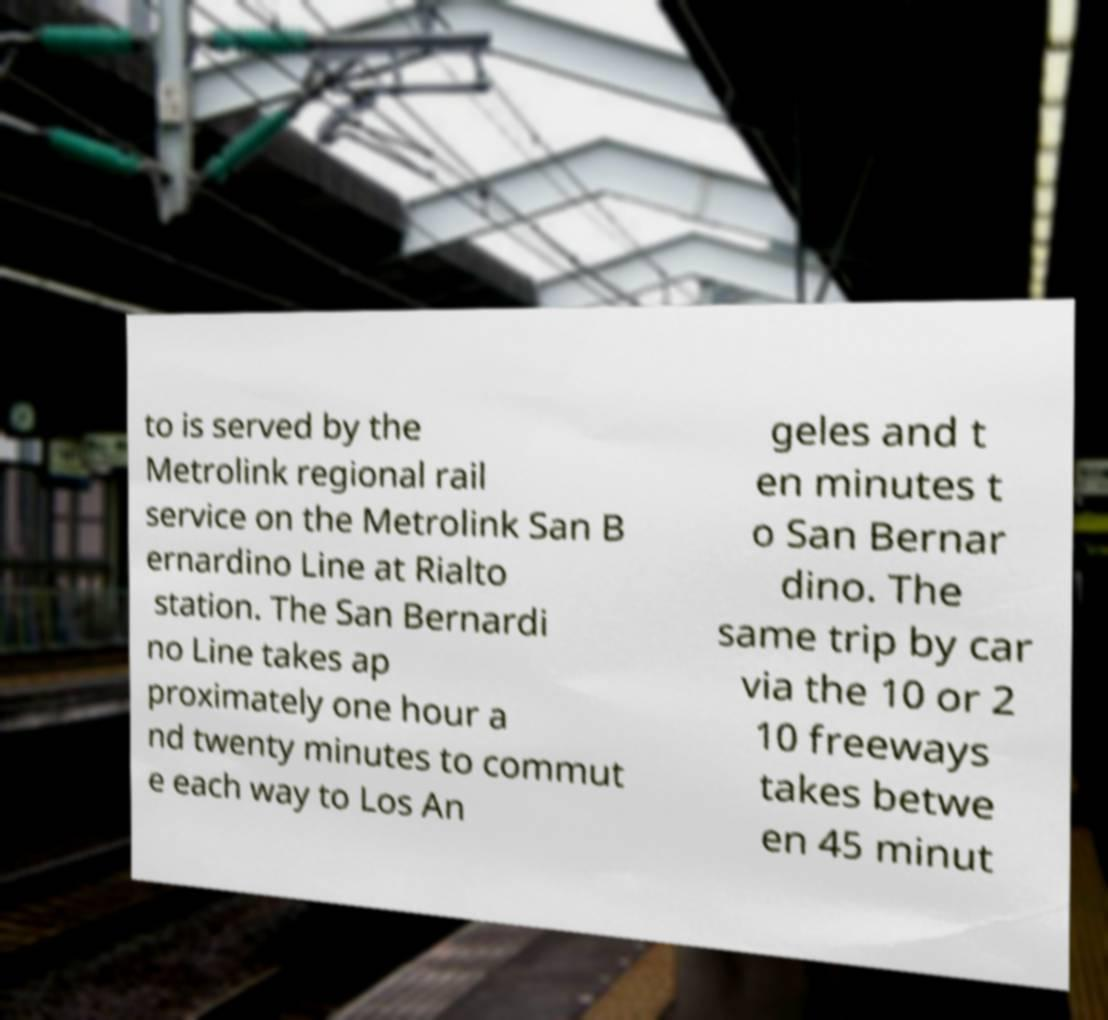There's text embedded in this image that I need extracted. Can you transcribe it verbatim? to is served by the Metrolink regional rail service on the Metrolink San B ernardino Line at Rialto station. The San Bernardi no Line takes ap proximately one hour a nd twenty minutes to commut e each way to Los An geles and t en minutes t o San Bernar dino. The same trip by car via the 10 or 2 10 freeways takes betwe en 45 minut 